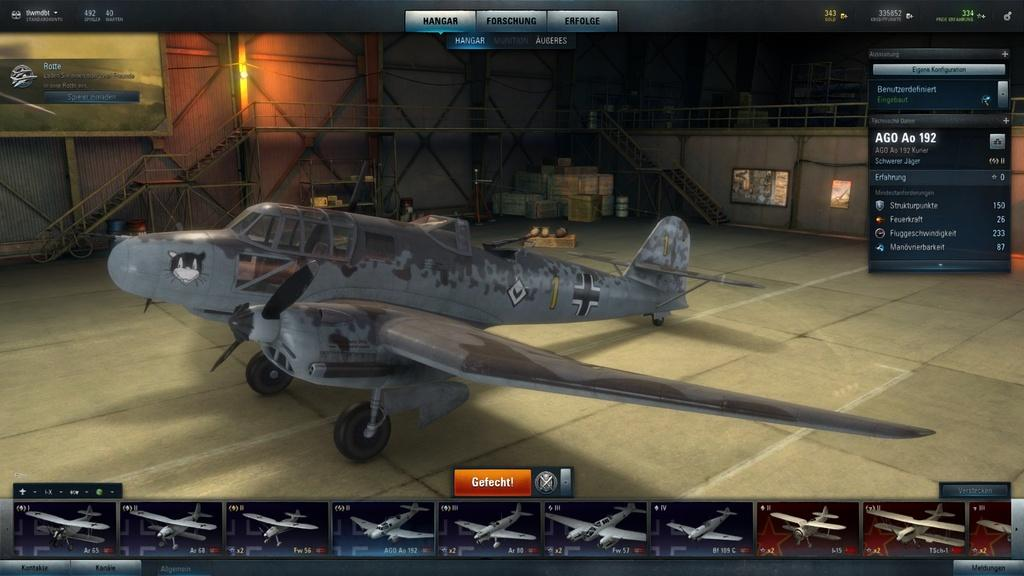<image>
Summarize the visual content of the image. an airplane with the number 1 on it on a computer screen 